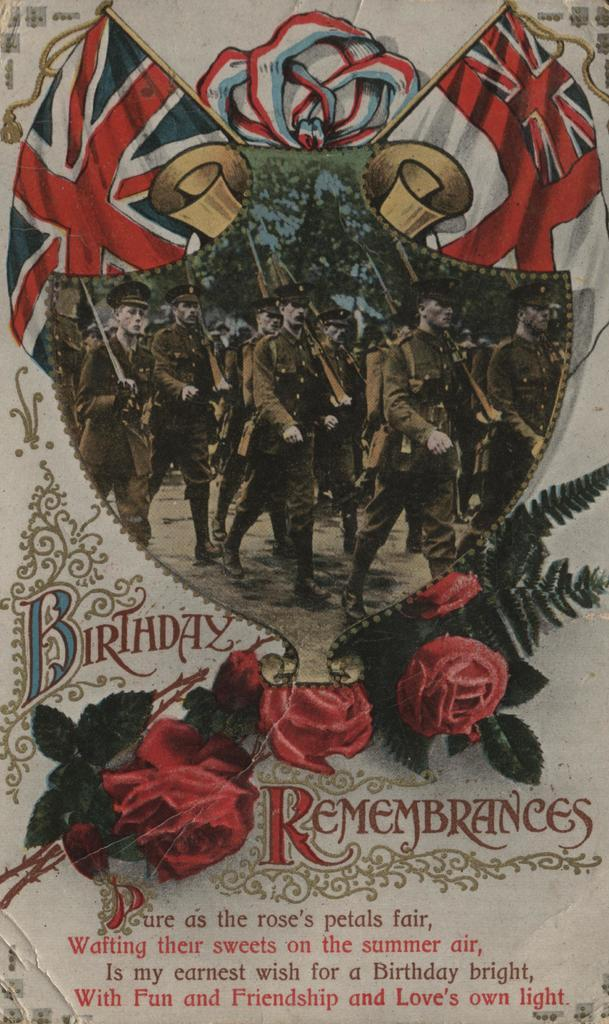Provide a one-sentence caption for the provided image. An antique style Birthday Rememberances card with a poem on it. 